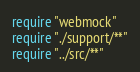Convert code to text. <code><loc_0><loc_0><loc_500><loc_500><_Crystal_>require "webmock"
require "./support/**"
require "../src/**"
</code> 